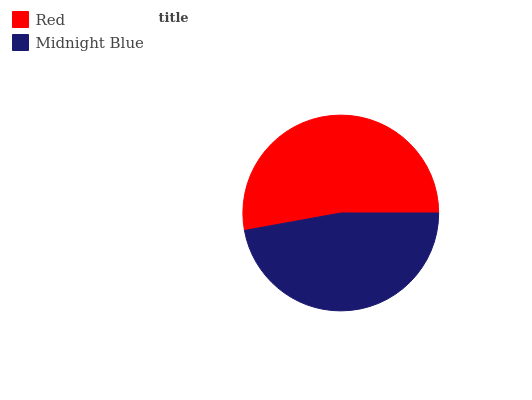Is Midnight Blue the minimum?
Answer yes or no. Yes. Is Red the maximum?
Answer yes or no. Yes. Is Midnight Blue the maximum?
Answer yes or no. No. Is Red greater than Midnight Blue?
Answer yes or no. Yes. Is Midnight Blue less than Red?
Answer yes or no. Yes. Is Midnight Blue greater than Red?
Answer yes or no. No. Is Red less than Midnight Blue?
Answer yes or no. No. Is Red the high median?
Answer yes or no. Yes. Is Midnight Blue the low median?
Answer yes or no. Yes. Is Midnight Blue the high median?
Answer yes or no. No. Is Red the low median?
Answer yes or no. No. 